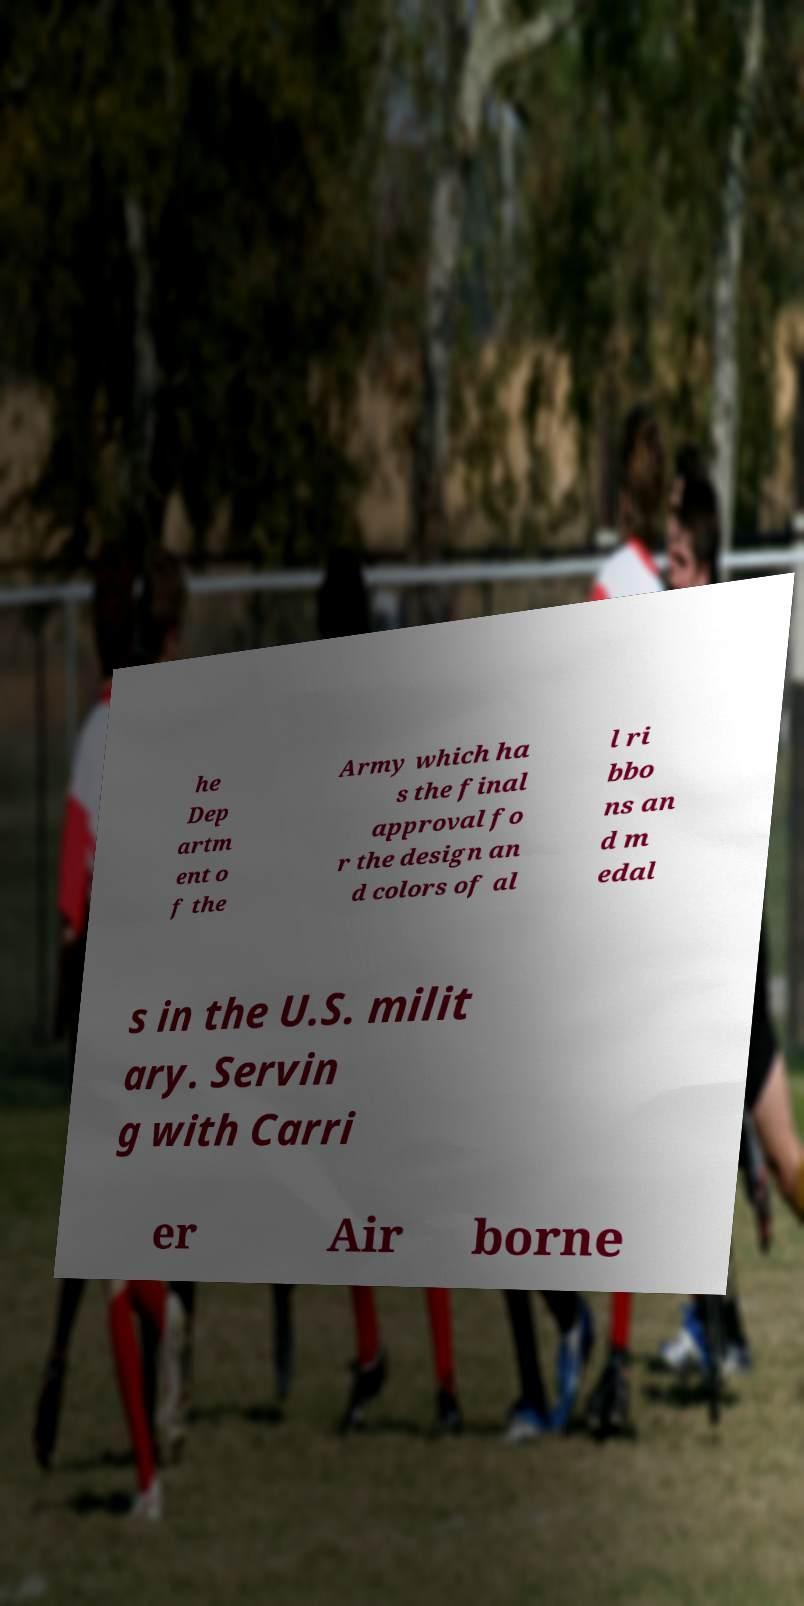For documentation purposes, I need the text within this image transcribed. Could you provide that? he Dep artm ent o f the Army which ha s the final approval fo r the design an d colors of al l ri bbo ns an d m edal s in the U.S. milit ary. Servin g with Carri er Air borne 